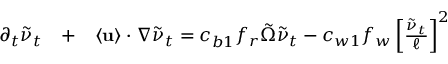Convert formula to latex. <formula><loc_0><loc_0><loc_500><loc_500>\begin{array} { r l r } { \partial _ { t } \tilde { \nu } _ { t } } & + } & { \langle { u } \rangle \cdot \nabla \tilde { \nu } _ { t } = c _ { b 1 } f _ { r } \tilde { \Omega } \tilde { \nu } _ { t } - c _ { w 1 } f _ { w } \left [ \frac { \tilde { \nu } _ { t } } { \ell } \right ] ^ { 2 } } \end{array}</formula> 